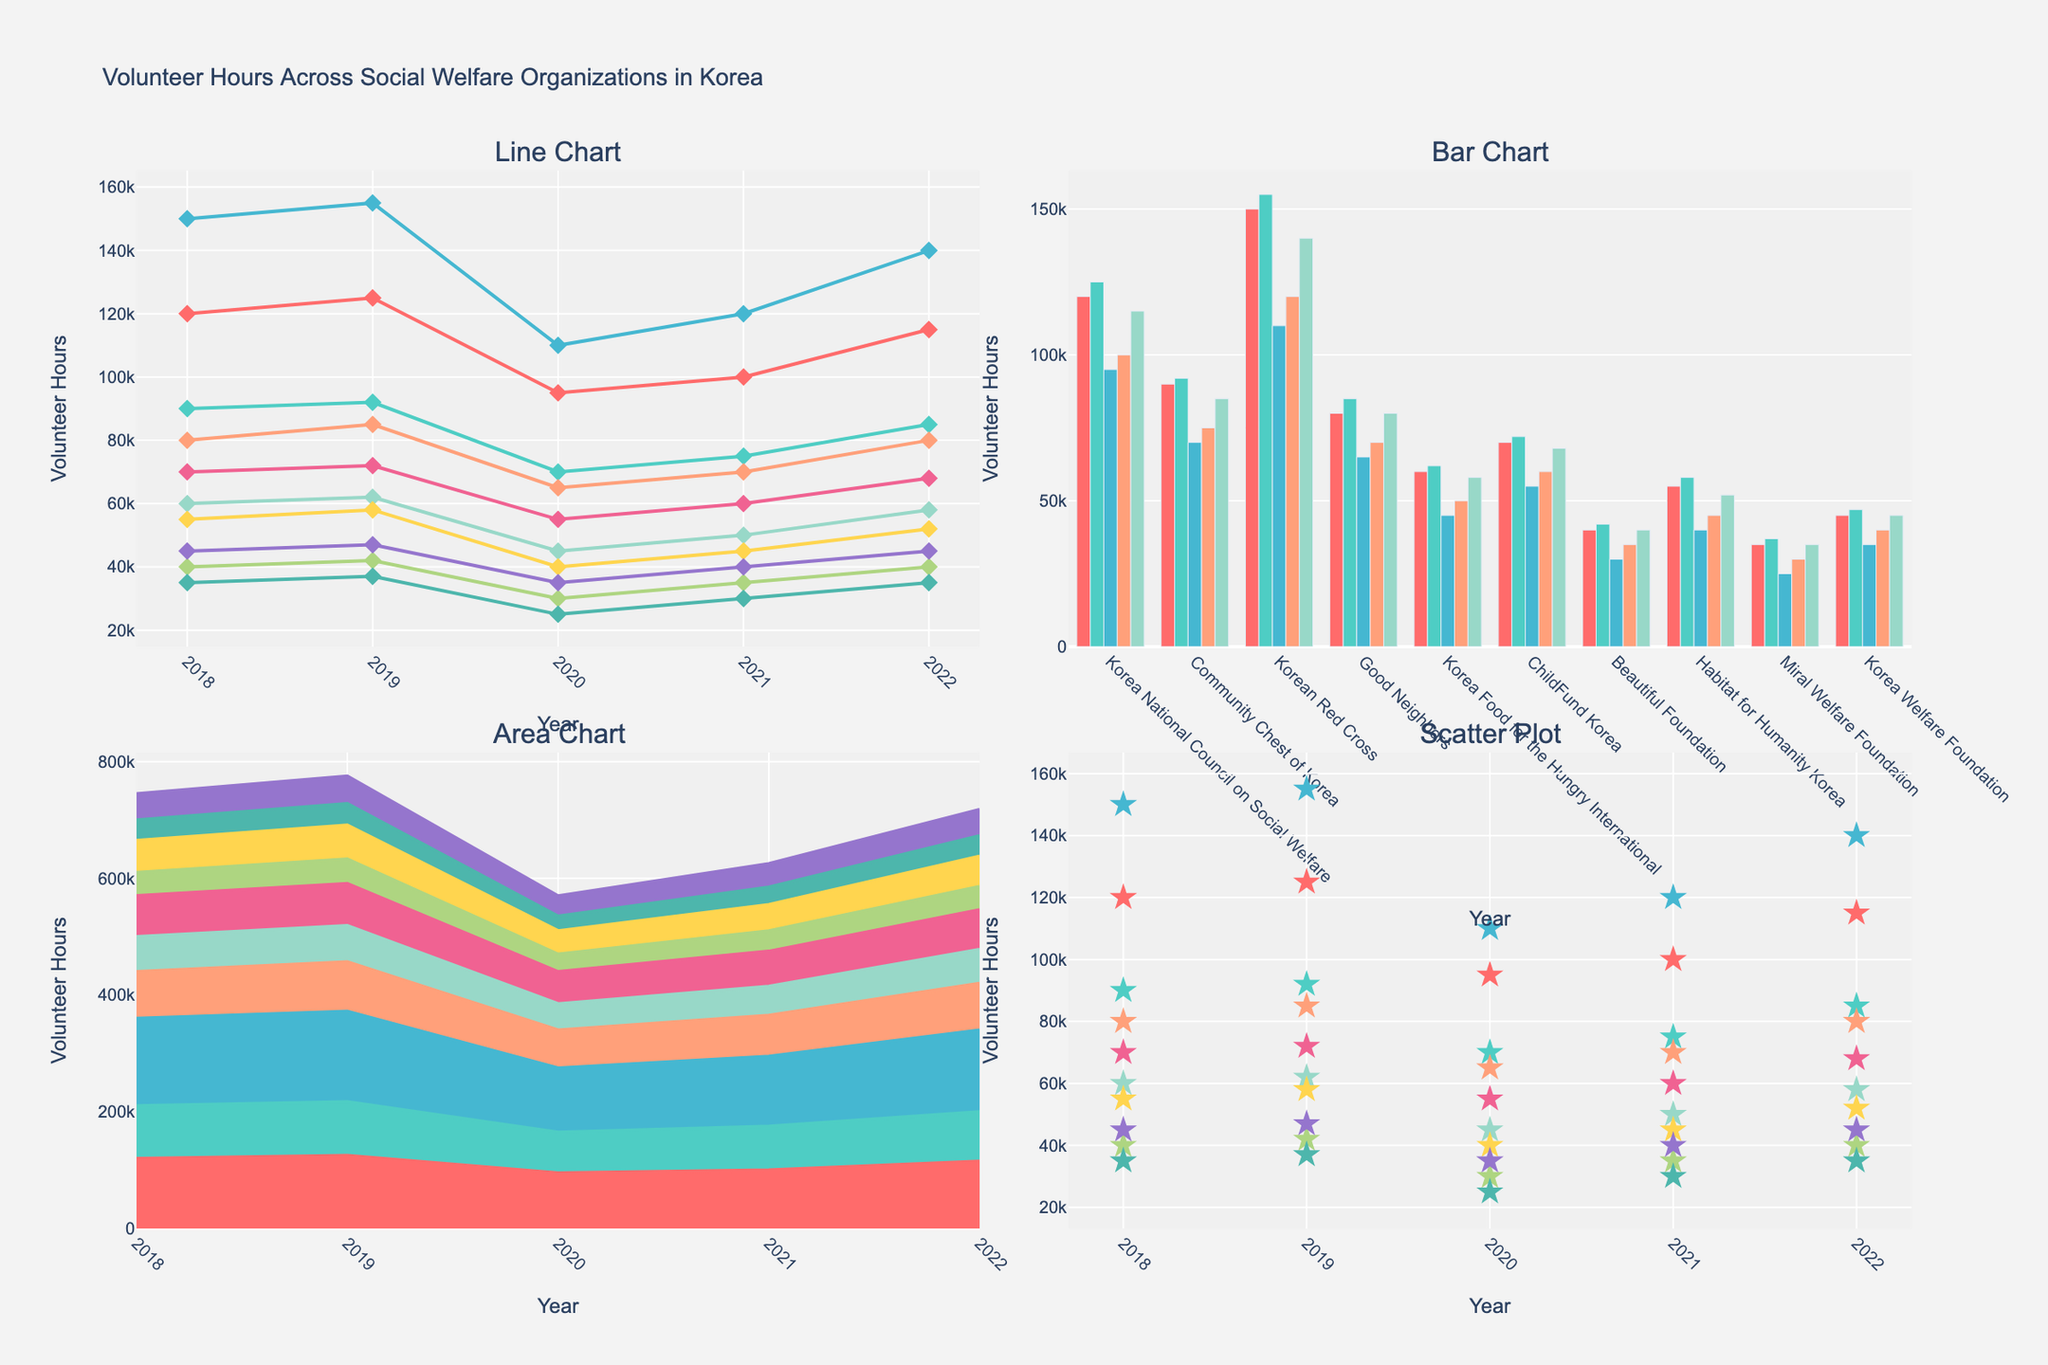Which age group has the highest percentage in all-female gyms? From the "Bar Chart" and other subplots, the 25-34 age group has the tallest pink bar and highest percentage line or area for all-female gyms.
Answer: 25-34 What is the title of the figure? The title is prominently displayed at the top of the figure.
Answer: Distribution of Age Groups in All-Female Gyms vs Co-Ed Facilities How does the percentage of the 18-24 age group compare between all-female gyms and co-ed facilities? By observing the height of the bars and points in the "Bar Chart" and other subplots, the percentage for all-female gyms (pink) is 28%, which is higher than co-ed facilities (purple) at 22%.
Answer: All-female gyms have a higher percentage What is the sum of percentages for the 25-34 and 35-44 age groups in all-female gyms? Summing the values from the "Bar Chart" and other subplots for these age groups: 35% (25-34) + 22% (35-44) = 57%.
Answer: 57% Which chart type shows the overlapping areas representing the distribution of age groups? This is depicted in the "Area Chart" subplot, where filled regions show the overlap.
Answer: Area chart In which age group is the difference in percentage the greatest between all-female gyms and co-ed facilities? Observing the figures, the 25-34 age group has the largest difference, where all-female gyms have 35% and co-ed facilities have 30%, a difference of 5%.
Answer: 25-34 Does any age group have the exact same percentage in both gym types? All age groups in all subplots reveal different values.
Answer: No How many age groups have a higher percentage in all-female gyms compared to co-ed facilities? From the plots, four age groups (18-24, 25-34, 55-64, and 65+) show higher values in all-female gyms compared to co-ed facilities.
Answer: 4 Which age group has the smallest percentage difference, and what is that difference? The 65+ age group has the smallest at 1% for all-female gyms and 2% for co-ed facilities, a difference of just 1%.
Answer: 65+, 1% What is the average percentage of all age groups in co-ed facilities? Summing up the percentages from the "Bar Chart" and dividing by the number of age groups: (22% + 30% + 25% + 15% + 6% + 2%) / 6 = 100% / 6 ≈ 16.67%.
Answer: 16.67% 